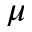<formula> <loc_0><loc_0><loc_500><loc_500>\mu</formula> 